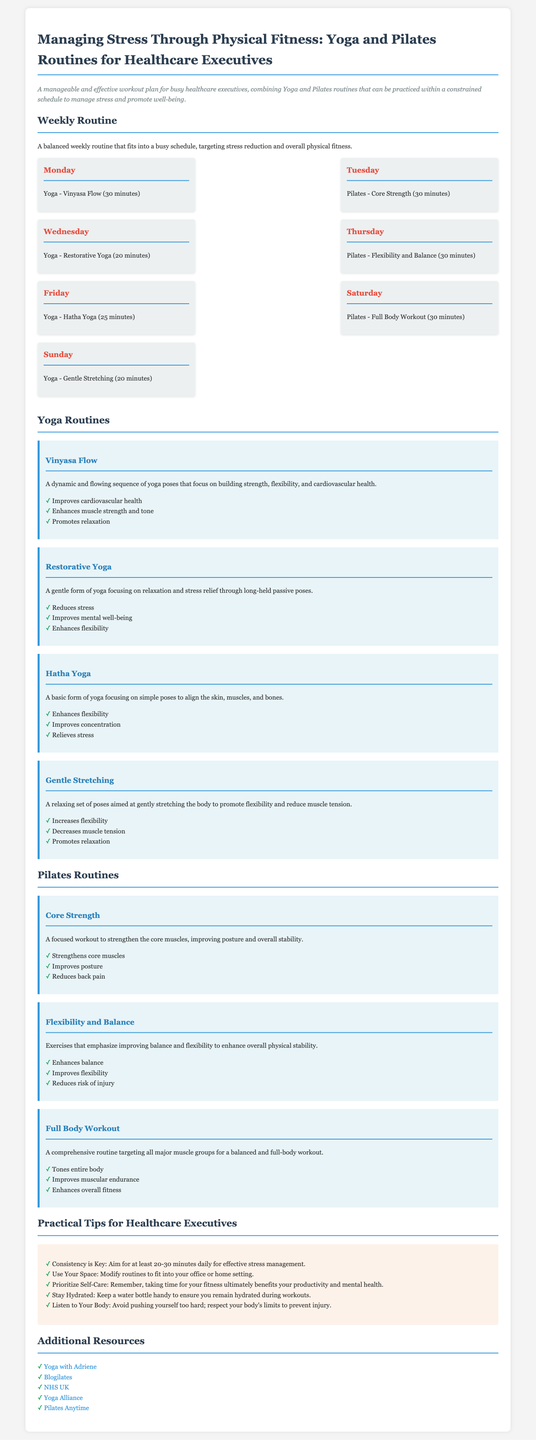What is the total duration of yoga on Monday? The yoga session on Monday is a Vinyasa Flow workout that lasts for 30 minutes.
Answer: 30 minutes Which day features Pilates for flexibility and balance? Pilates for flexibility and balance is scheduled for Thursday.
Answer: Thursday How many minutes is dedicated to Restorative Yoga? Restorative Yoga is practiced for 20 minutes on Wednesday.
Answer: 20 minutes What is the main focus of the Core Strength Pilates routine? The Core Strength Pilates routine primarily focuses on strengthening core muscles.
Answer: Strengthening core muscles What consistent recommendation is provided for effective stress management? The document emphasizes consistency, suggesting at least 20-30 minutes of exercise daily for effective stress management.
Answer: 20-30 minutes daily Which yoga routine is designed to relieve stress? The Restorative Yoga routine is specifically aimed at reducing stress.
Answer: Restorative Yoga How many distinct yoga routines are outlined in the document? The document outlines four distinct yoga routines.
Answer: Four What is one practical tip related to self-care mentioned? One practical tip is to prioritize self-care to improve productivity and mental health.
Answer: Prioritize self-care Which additional resource is mentioned for Yoga? The resource mentioned for Yoga is "Yoga with Adriene."
Answer: Yoga with Adriene 